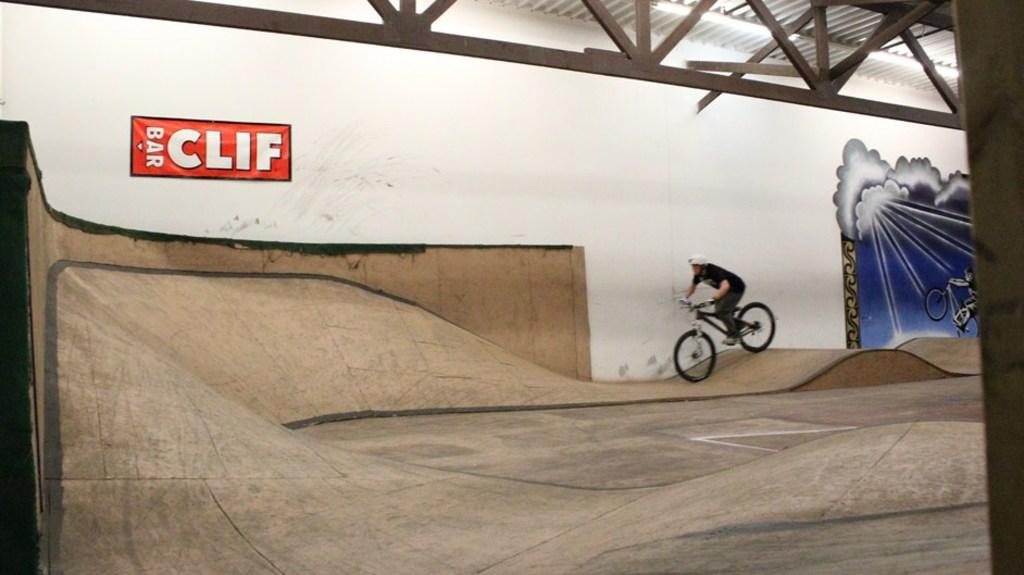What is the person in the image doing? There is a person riding a bicycle on a path in the image. What can be seen in the background of the image? There are grills, electric lights, and a shed in the image. Are there any decorative elements in the image? Yes, there are paintings on the wall in the image. What type of noise can be heard coming from the appliance in the image? There is no appliance present in the image, so it's not possible to determine what noise might be heard. How many nails are visible in the image? There is no mention of nails in the provided facts, so it's not possible to determine how many nails are visible. 